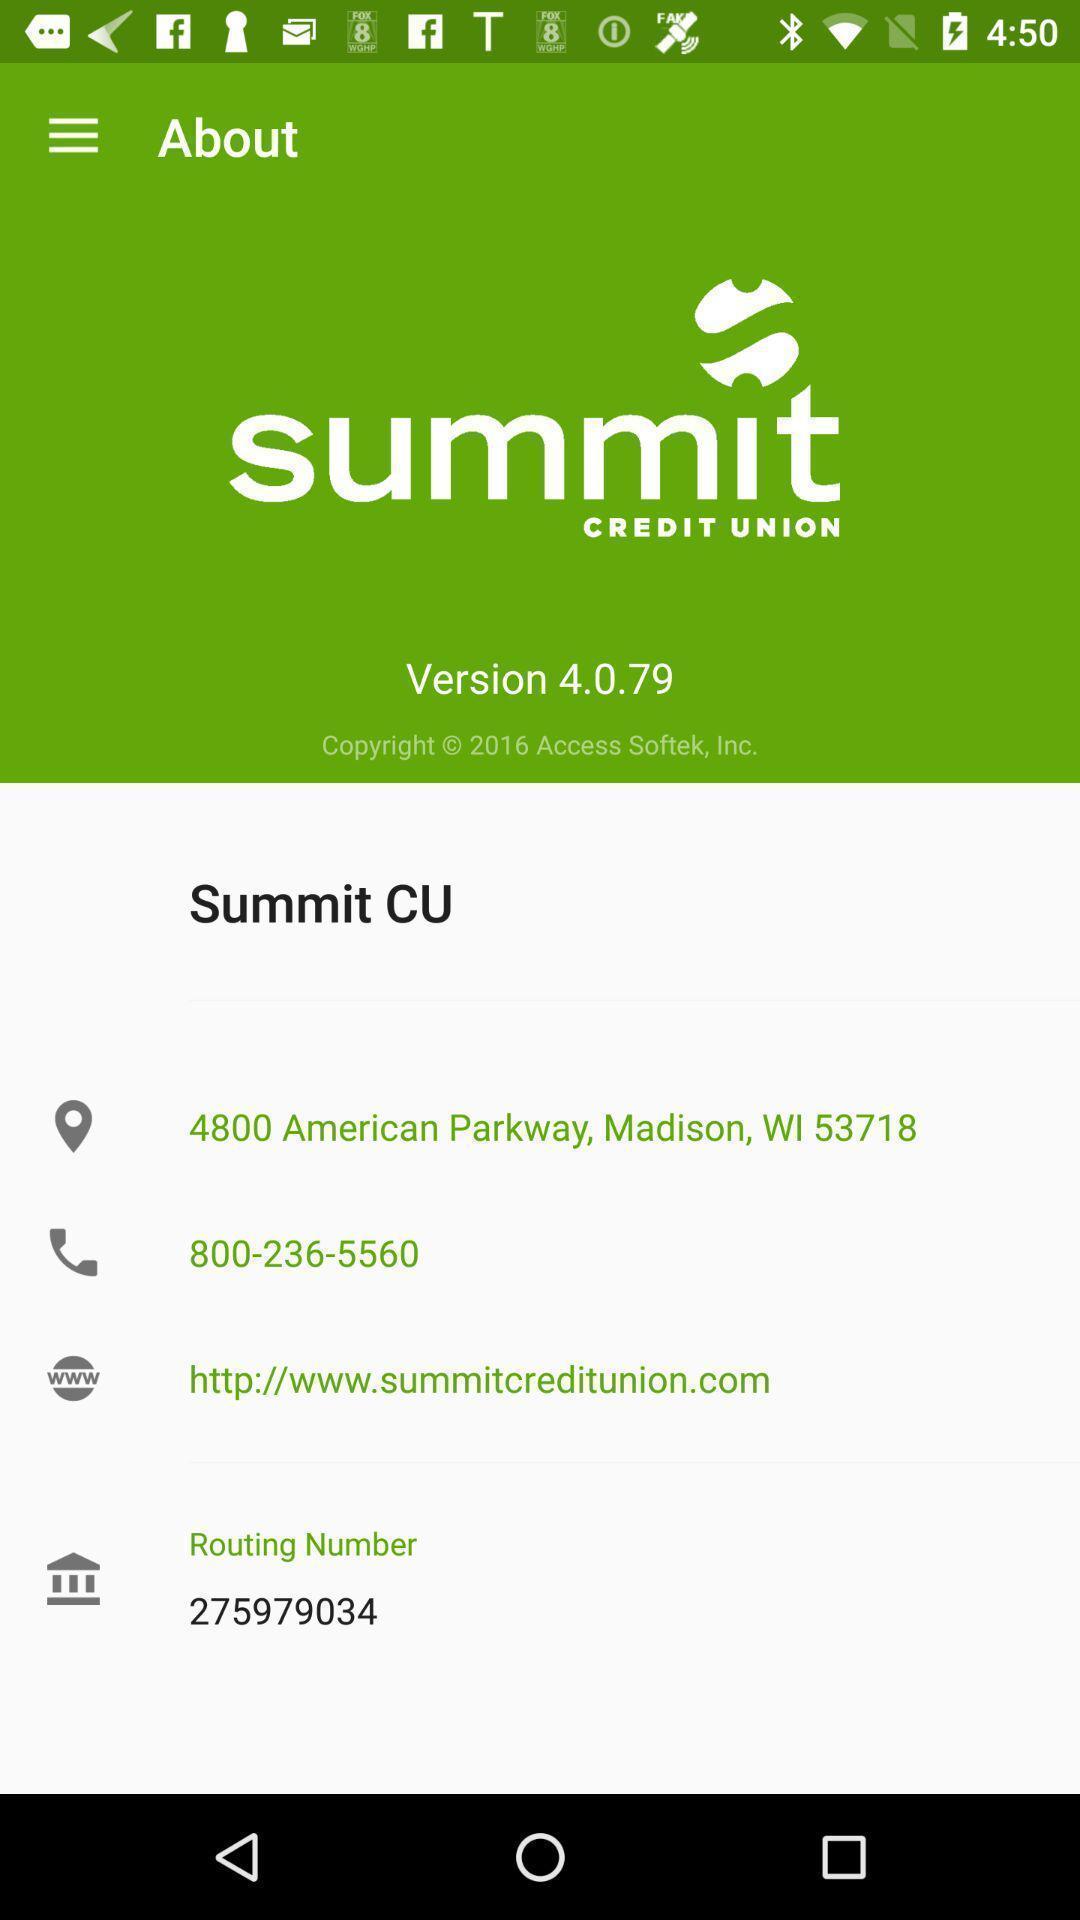Provide a detailed account of this screenshot. Screen displaying information about a banking application. 